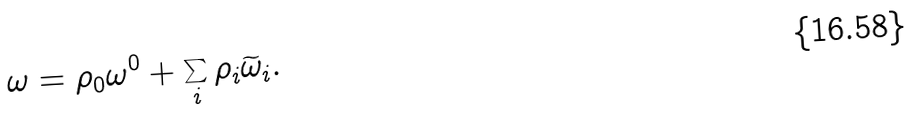<formula> <loc_0><loc_0><loc_500><loc_500>\omega = \rho _ { 0 } \omega ^ { 0 } + \sum _ { i } \rho _ { i } \widetilde { \omega } _ { i } .</formula> 